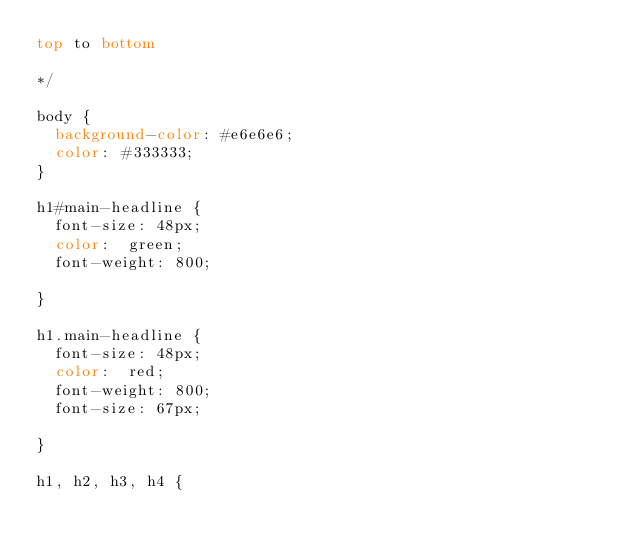<code> <loc_0><loc_0><loc_500><loc_500><_CSS_>top to bottom

*/

body {
	background-color: #e6e6e6;
	color: #333333;
}

h1#main-headline {
	font-size: 48px;
	color:  green;
	font-weight: 800;

}

h1.main-headline {
	font-size: 48px;
	color:  red;
	font-weight: 800;
	font-size: 67px;

}

h1, h2, h3, h4 {</code> 